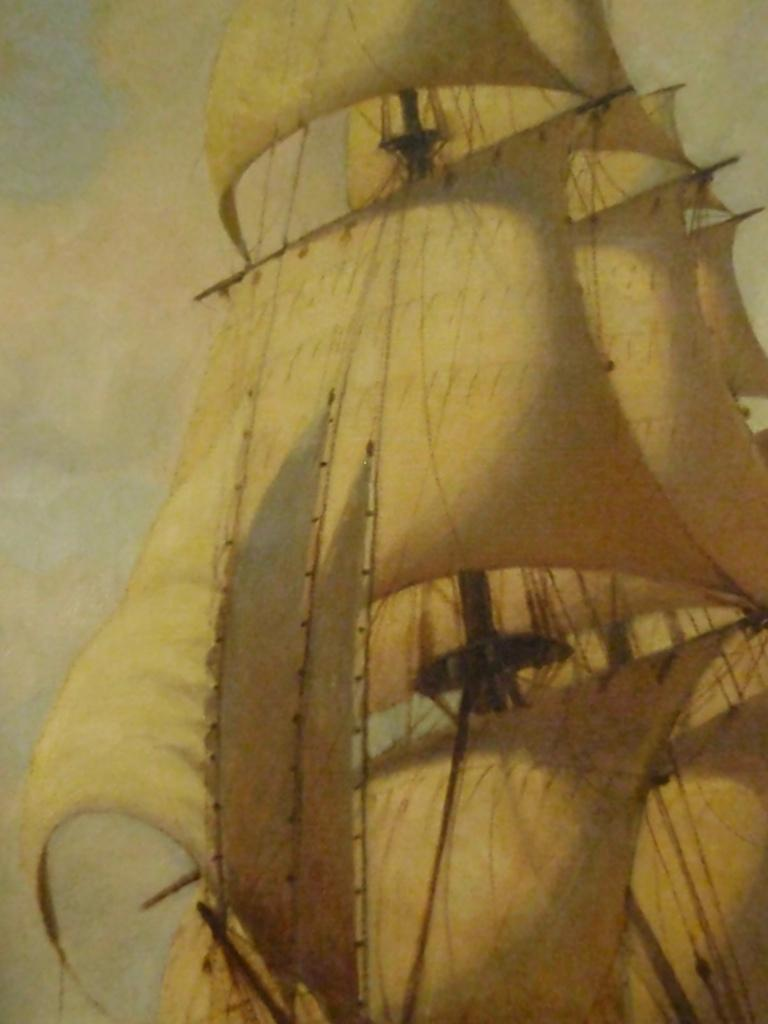What is the main subject of the picture? The main subject of the picture is a ship. What is the ship doing in the picture? The ship is sailing. What is the condition of the sky in the picture? The sky is clear in the picture. How many planes can be seen flying in the sky in the image? There are no planes visible in the image; it features a ship sailing on the water. What type of interest does the ship have in the wire? There is no wire present in the image, and therefore no such interaction can be observed. 